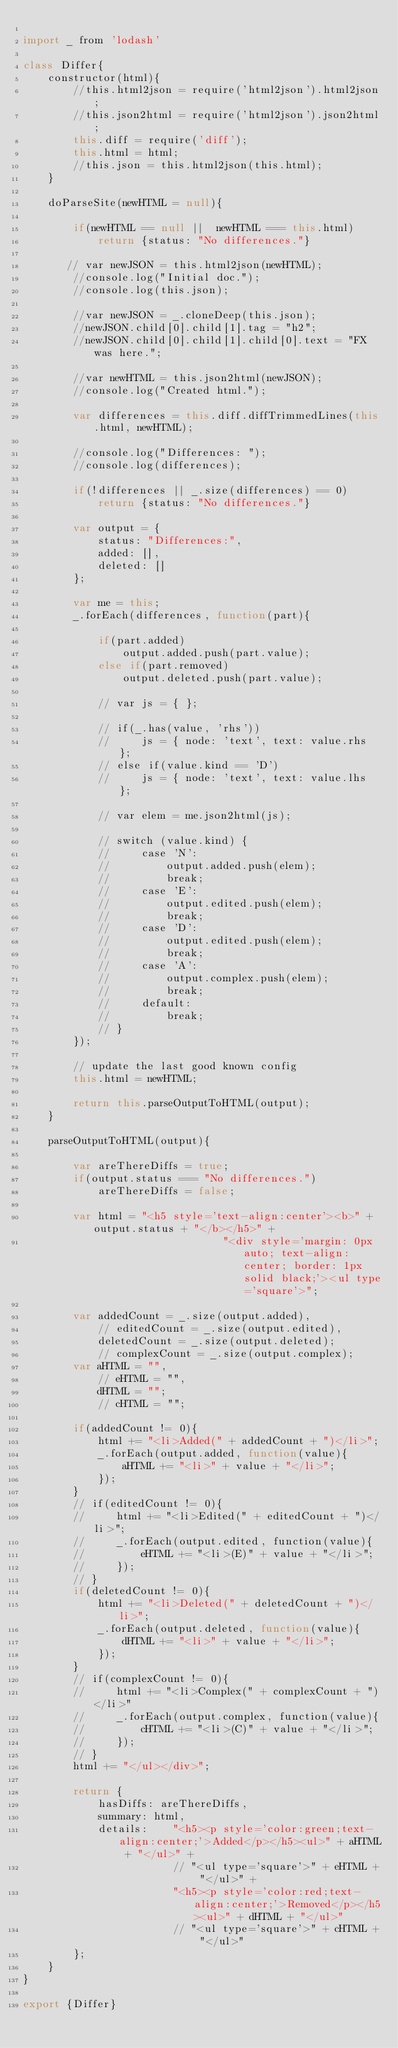Convert code to text. <code><loc_0><loc_0><loc_500><loc_500><_JavaScript_>
import _ from 'lodash'

class Differ{
    constructor(html){
        //this.html2json = require('html2json').html2json;
        //this.json2html = require('html2json').json2html;
        this.diff = require('diff');
        this.html = html;
        //this.json = this.html2json(this.html);
    }

    doParseSite(newHTML = null){
        
        if(newHTML == null ||  newHTML === this.html)
            return {status: "No differences."}
        
       // var newJSON = this.html2json(newHTML);
        //console.log("Initial doc.");
        //console.log(this.json);

        //var newJSON = _.cloneDeep(this.json);
        //newJSON.child[0].child[1].tag = "h2";
        //newJSON.child[0].child[1].child[0].text = "FX was here.";

        //var newHTML = this.json2html(newJSON);
        //console.log("Created html.");

        var differences = this.diff.diffTrimmedLines(this.html, newHTML);

        //console.log("Differences: ");
        //console.log(differences);

        if(!differences || _.size(differences) == 0)
            return {status: "No differences."}
        
        var output = {
            status: "Differences:",
            added: [],
            deleted: []
        };

        var me = this;
        _.forEach(differences, function(part){
            
            if(part.added)
                output.added.push(part.value);
            else if(part.removed)
                output.deleted.push(part.value);

            // var js = { };

            // if(_.has(value, 'rhs'))
            //     js = { node: 'text', text: value.rhs };
            // else if(value.kind == 'D')
            //     js = { node: 'text', text: value.lhs };

            // var elem = me.json2html(js);

            // switch (value.kind) {
            //     case 'N':
            //         output.added.push(elem);
            //         break;
            //     case 'E':
            //         output.edited.push(elem);
            //         break;
            //     case 'D':
            //         output.edited.push(elem);
            //         break;
            //     case 'A':
            //         output.complex.push(elem);
            //         break;
            //     default:
            //         break;
            // }
        });

        // update the last good known config
        this.html = newHTML;
        
        return this.parseOutputToHTML(output);
    }

    parseOutputToHTML(output){

        var areThereDiffs = true;
        if(output.status === "No differences.")
            areThereDiffs = false;
        
        var html = "<h5 style='text-align:center'><b>" + output.status + "</b></h5>" +
                                "<div style='margin: 0px auto; text-align: center; border: 1px solid black;'><ul type='square'>";

        var addedCount = _.size(output.added),
            // editedCount = _.size(output.edited),
            deletedCount = _.size(output.deleted);
            // complexCount = _.size(output.complex);
        var aHTML = "",
            // eHTML = "",
            dHTML = "";
            // cHTML = "";

        if(addedCount != 0){
            html += "<li>Added(" + addedCount + ")</li>";
            _.forEach(output.added, function(value){
                aHTML += "<li>" + value + "</li>";
            });
        }
        // if(editedCount != 0){
        //     html += "<li>Edited(" + editedCount + ")</li>";
        //     _.forEach(output.edited, function(value){
        //         eHTML += "<li>(E)" + value + "</li>";
        //     });
        // }
        if(deletedCount != 0){
            html += "<li>Deleted(" + deletedCount + ")</li>";
            _.forEach(output.deleted, function(value){
                dHTML += "<li>" + value + "</li>";
            });
        }
        // if(complexCount != 0){
        //     html += "<li>Complex(" + complexCount + ")</li>"
        //     _.forEach(output.complex, function(value){
        //         cHTML += "<li>(C)" + value + "</li>";
        //     });
        // }
        html += "</ul></div>";

        return {
            hasDiffs: areThereDiffs,
            summary: html,
            details:    "<h5><p style='color:green;text-align:center;'>Added</p></h5><ul>" + aHTML + "</ul>" + 
                        // "<ul type='square'>" + eHTML + "</ul>" + 
                        "<h5><p style='color:red;text-align:center;'>Removed</p></h5><ul>" + dHTML + "</ul>"
                        // "<ul type='square'>" + cHTML + "</ul>"
        };
    }
}

export {Differ}</code> 